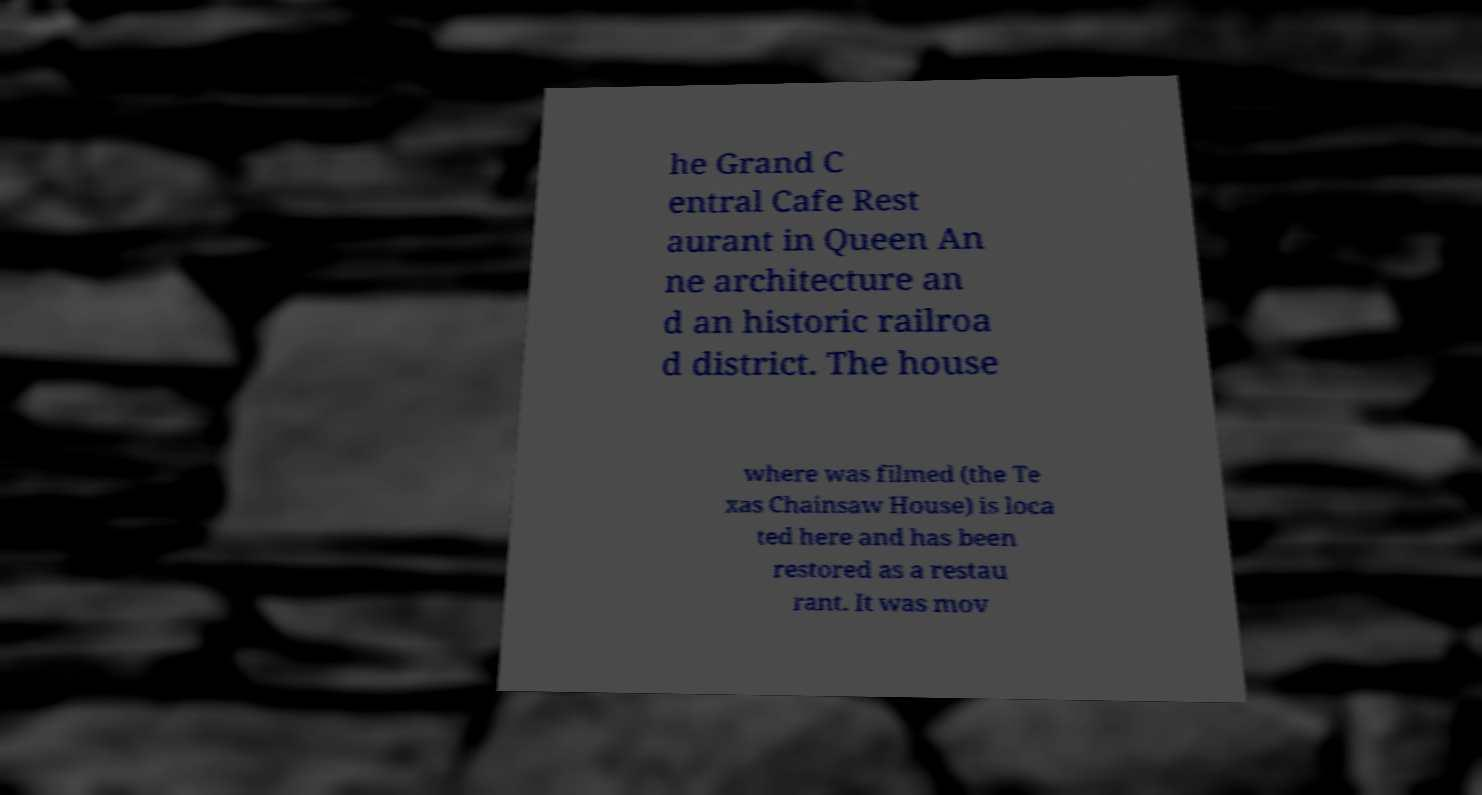For documentation purposes, I need the text within this image transcribed. Could you provide that? he Grand C entral Cafe Rest aurant in Queen An ne architecture an d an historic railroa d district. The house where was filmed (the Te xas Chainsaw House) is loca ted here and has been restored as a restau rant. It was mov 